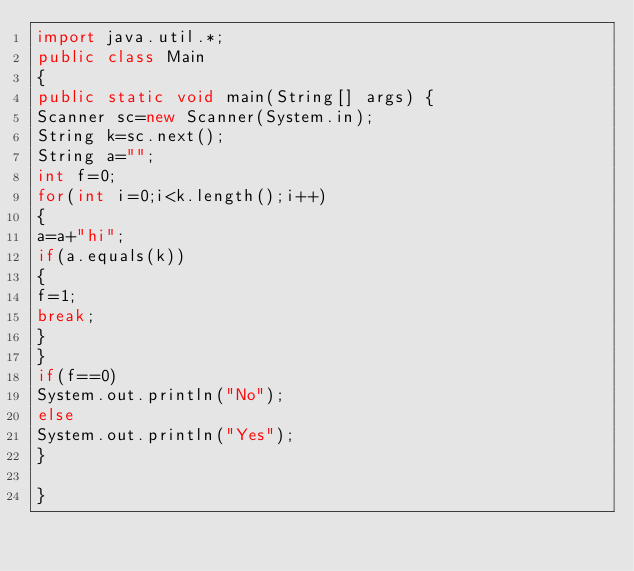Convert code to text. <code><loc_0><loc_0><loc_500><loc_500><_Java_>import java.util.*;
public class Main
{
public static void main(String[] args) {
Scanner sc=new Scanner(System.in);
String k=sc.next();
String a="";
int f=0;
for(int i=0;i<k.length();i++)
{
a=a+"hi";
if(a.equals(k))
{
f=1;
break;
}
}
if(f==0)
System.out.println("No");
else
System.out.println("Yes");
}

}</code> 